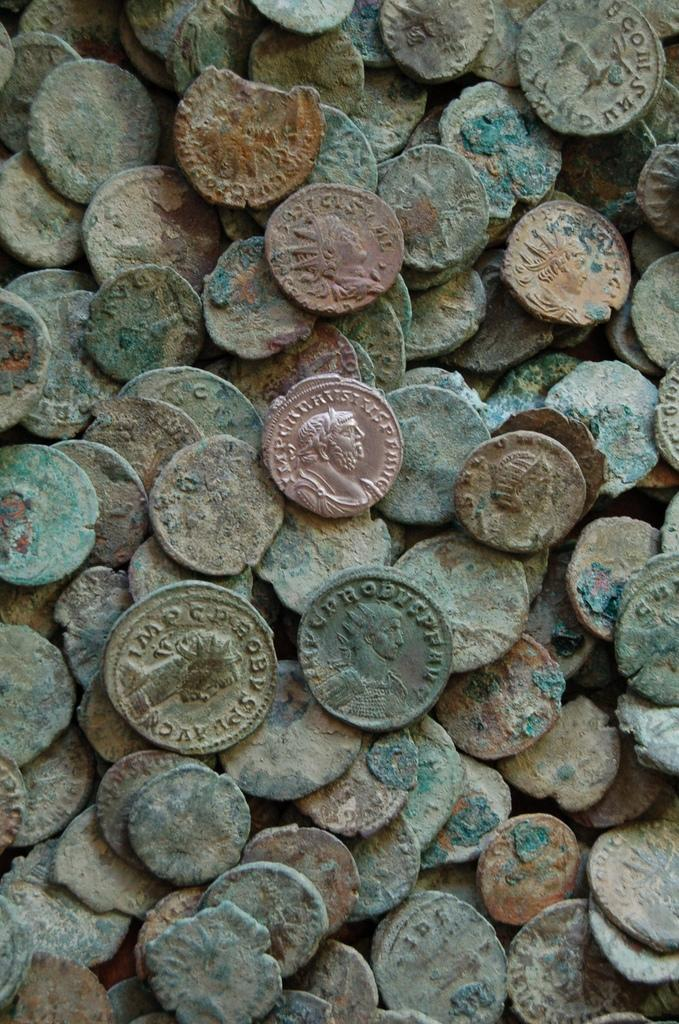What objects are present in the image? There is a group of coins in the image. Can you describe the appearance of the coins? The coins appear to be round and metallic, with different designs and values. How are the coins arranged in the image? The coins are grouped together, possibly in a pile or scattered on a surface. What flavor of ice cream is being served in the cellar, as depicted in the image? There is no ice cream or cellar present in the image; it only features a group of coins. 